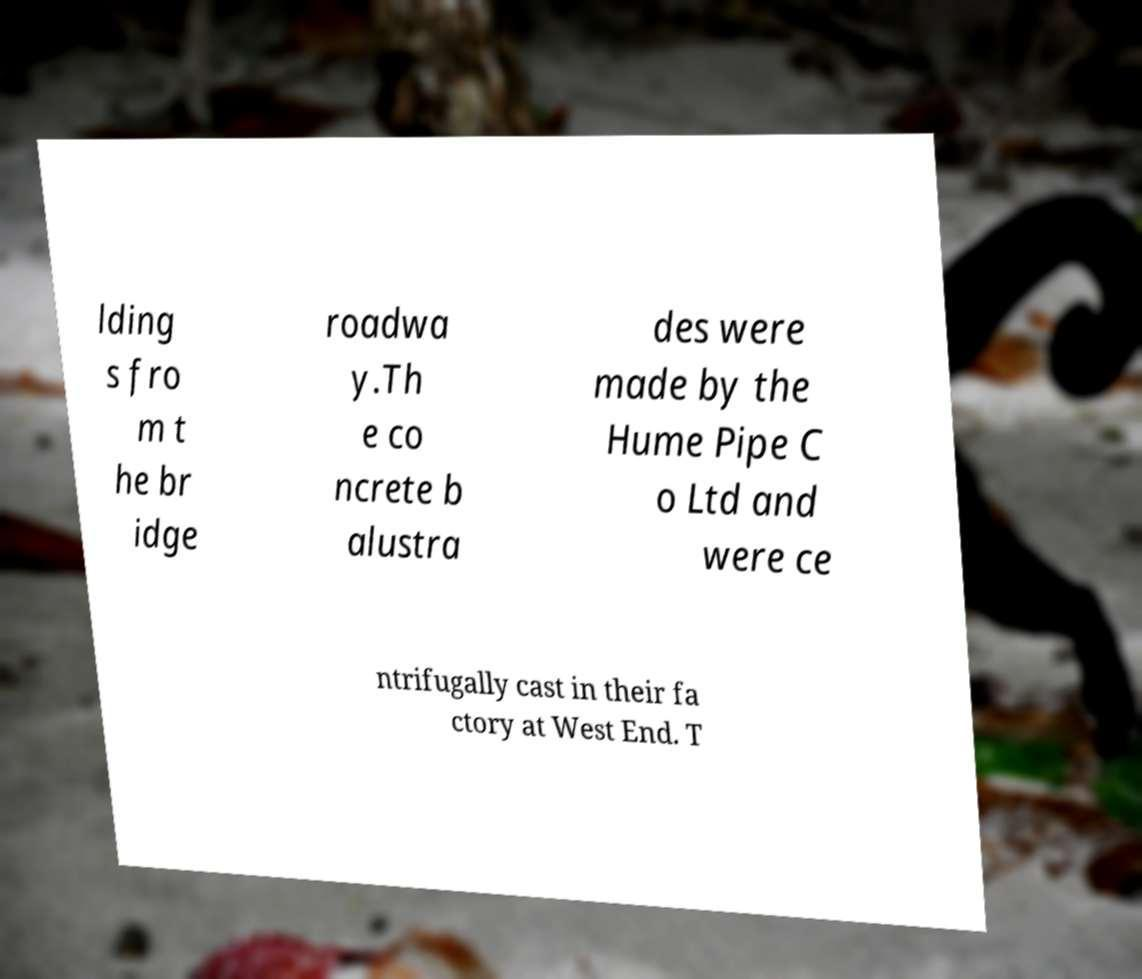There's text embedded in this image that I need extracted. Can you transcribe it verbatim? lding s fro m t he br idge roadwa y.Th e co ncrete b alustra des were made by the Hume Pipe C o Ltd and were ce ntrifugally cast in their fa ctory at West End. T 